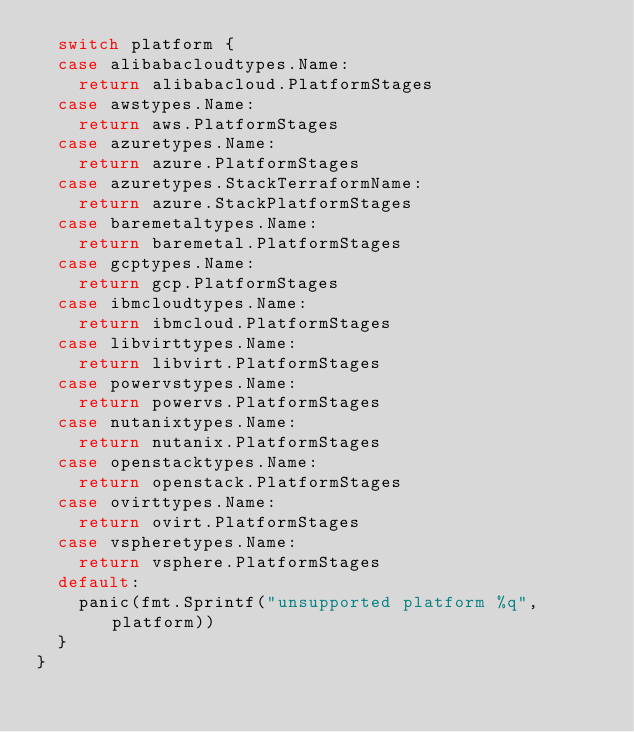Convert code to text. <code><loc_0><loc_0><loc_500><loc_500><_Go_>	switch platform {
	case alibabacloudtypes.Name:
		return alibabacloud.PlatformStages
	case awstypes.Name:
		return aws.PlatformStages
	case azuretypes.Name:
		return azure.PlatformStages
	case azuretypes.StackTerraformName:
		return azure.StackPlatformStages
	case baremetaltypes.Name:
		return baremetal.PlatformStages
	case gcptypes.Name:
		return gcp.PlatformStages
	case ibmcloudtypes.Name:
		return ibmcloud.PlatformStages
	case libvirttypes.Name:
		return libvirt.PlatformStages
	case powervstypes.Name:
		return powervs.PlatformStages
	case nutanixtypes.Name:
		return nutanix.PlatformStages
	case openstacktypes.Name:
		return openstack.PlatformStages
	case ovirttypes.Name:
		return ovirt.PlatformStages
	case vspheretypes.Name:
		return vsphere.PlatformStages
	default:
		panic(fmt.Sprintf("unsupported platform %q", platform))
	}
}
</code> 